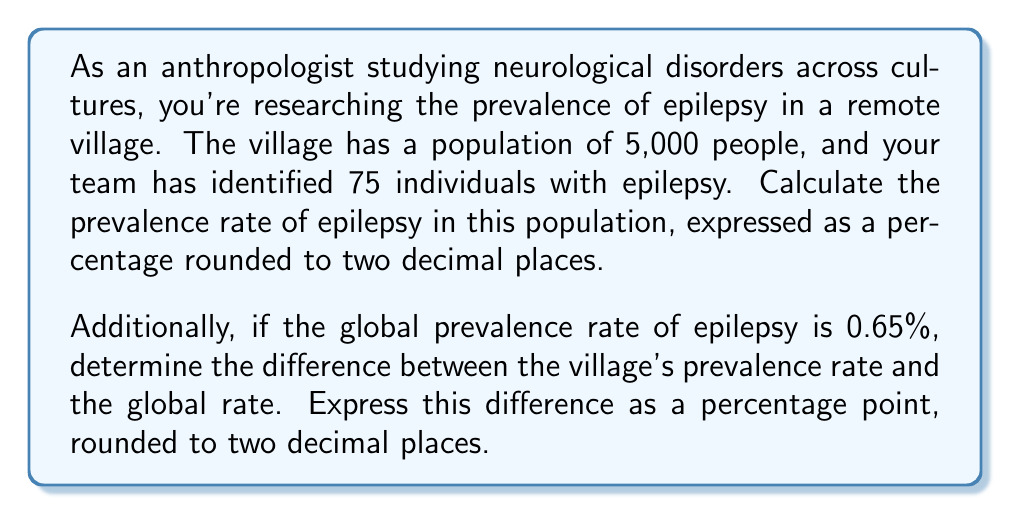Solve this math problem. To solve this problem, we'll follow these steps:

1. Calculate the prevalence rate of epilepsy in the village:
   The prevalence rate is the number of cases divided by the total population, expressed as a percentage.

   $$\text{Prevalence Rate} = \frac{\text{Number of Cases}}{\text{Total Population}} \times 100\%$$

   $$\text{Prevalence Rate} = \frac{75}{5,000} \times 100\% = 0.015 \times 100\% = 1.50\%$$

2. Compare the village's prevalence rate to the global rate:
   To find the difference, we subtract the global rate from the village's rate.

   $$\text{Difference} = \text{Village Rate} - \text{Global Rate}$$
   $$\text{Difference} = 1.50\% - 0.65\% = 0.85\text{ percentage points}$$

Note: The difference is expressed in percentage points, not as a percentage of the global rate. This is because we're dealing with the arithmetic difference between two percentages.
Answer: The prevalence rate of epilepsy in the village is 1.50%.
The difference between the village's prevalence rate and the global rate is 0.85 percentage points. 